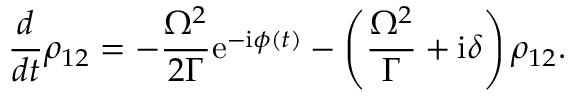Convert formula to latex. <formula><loc_0><loc_0><loc_500><loc_500>\frac { d } { d t } \rho _ { 1 2 } = - \frac { \Omega ^ { 2 } } { 2 \Gamma } e ^ { - i \phi ( t ) } - \left ( \frac { \Omega ^ { 2 } } { \Gamma } + i \delta \right ) \rho _ { 1 2 } .</formula> 